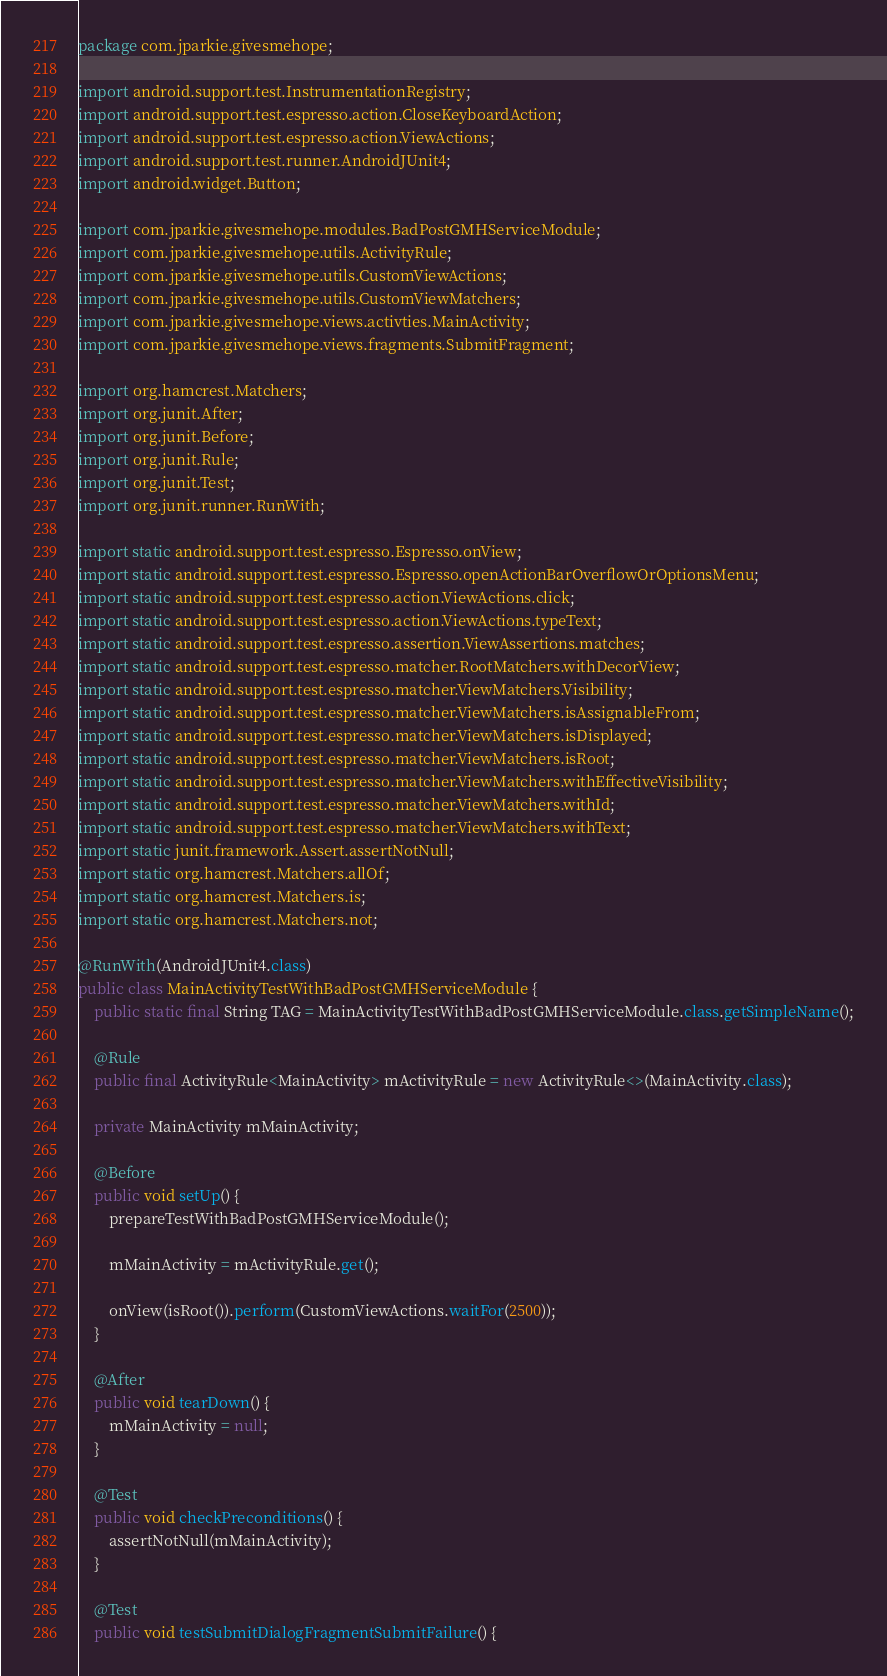Convert code to text. <code><loc_0><loc_0><loc_500><loc_500><_Java_>package com.jparkie.givesmehope;

import android.support.test.InstrumentationRegistry;
import android.support.test.espresso.action.CloseKeyboardAction;
import android.support.test.espresso.action.ViewActions;
import android.support.test.runner.AndroidJUnit4;
import android.widget.Button;

import com.jparkie.givesmehope.modules.BadPostGMHServiceModule;
import com.jparkie.givesmehope.utils.ActivityRule;
import com.jparkie.givesmehope.utils.CustomViewActions;
import com.jparkie.givesmehope.utils.CustomViewMatchers;
import com.jparkie.givesmehope.views.activties.MainActivity;
import com.jparkie.givesmehope.views.fragments.SubmitFragment;

import org.hamcrest.Matchers;
import org.junit.After;
import org.junit.Before;
import org.junit.Rule;
import org.junit.Test;
import org.junit.runner.RunWith;

import static android.support.test.espresso.Espresso.onView;
import static android.support.test.espresso.Espresso.openActionBarOverflowOrOptionsMenu;
import static android.support.test.espresso.action.ViewActions.click;
import static android.support.test.espresso.action.ViewActions.typeText;
import static android.support.test.espresso.assertion.ViewAssertions.matches;
import static android.support.test.espresso.matcher.RootMatchers.withDecorView;
import static android.support.test.espresso.matcher.ViewMatchers.Visibility;
import static android.support.test.espresso.matcher.ViewMatchers.isAssignableFrom;
import static android.support.test.espresso.matcher.ViewMatchers.isDisplayed;
import static android.support.test.espresso.matcher.ViewMatchers.isRoot;
import static android.support.test.espresso.matcher.ViewMatchers.withEffectiveVisibility;
import static android.support.test.espresso.matcher.ViewMatchers.withId;
import static android.support.test.espresso.matcher.ViewMatchers.withText;
import static junit.framework.Assert.assertNotNull;
import static org.hamcrest.Matchers.allOf;
import static org.hamcrest.Matchers.is;
import static org.hamcrest.Matchers.not;

@RunWith(AndroidJUnit4.class)
public class MainActivityTestWithBadPostGMHServiceModule {
    public static final String TAG = MainActivityTestWithBadPostGMHServiceModule.class.getSimpleName();

    @Rule
    public final ActivityRule<MainActivity> mActivityRule = new ActivityRule<>(MainActivity.class);

    private MainActivity mMainActivity;

    @Before
    public void setUp() {
        prepareTestWithBadPostGMHServiceModule();

        mMainActivity = mActivityRule.get();

        onView(isRoot()).perform(CustomViewActions.waitFor(2500));
    }

    @After
    public void tearDown() {
        mMainActivity = null;
    }

    @Test
    public void checkPreconditions() {
        assertNotNull(mMainActivity);
    }

    @Test
    public void testSubmitDialogFragmentSubmitFailure() {</code> 